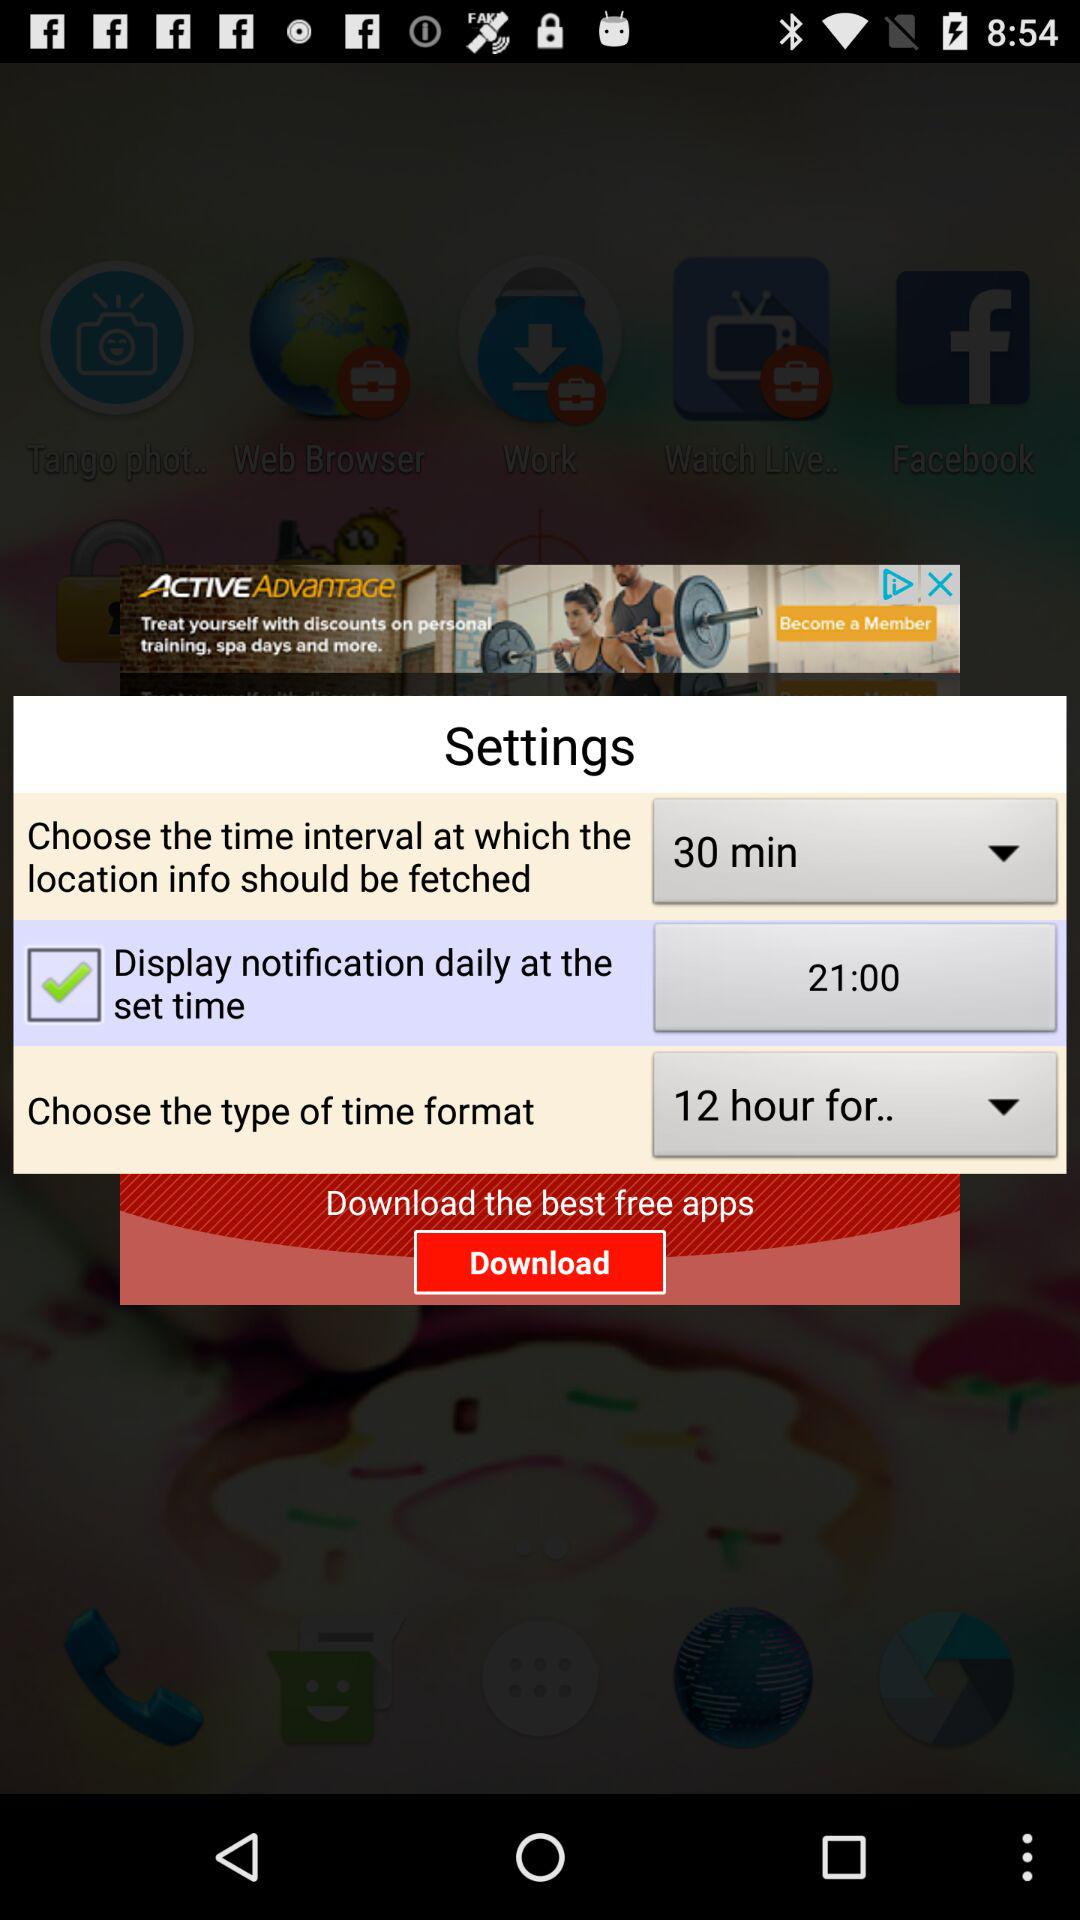What is the chosen time interval? The chosen time interval is 30 minutes. 